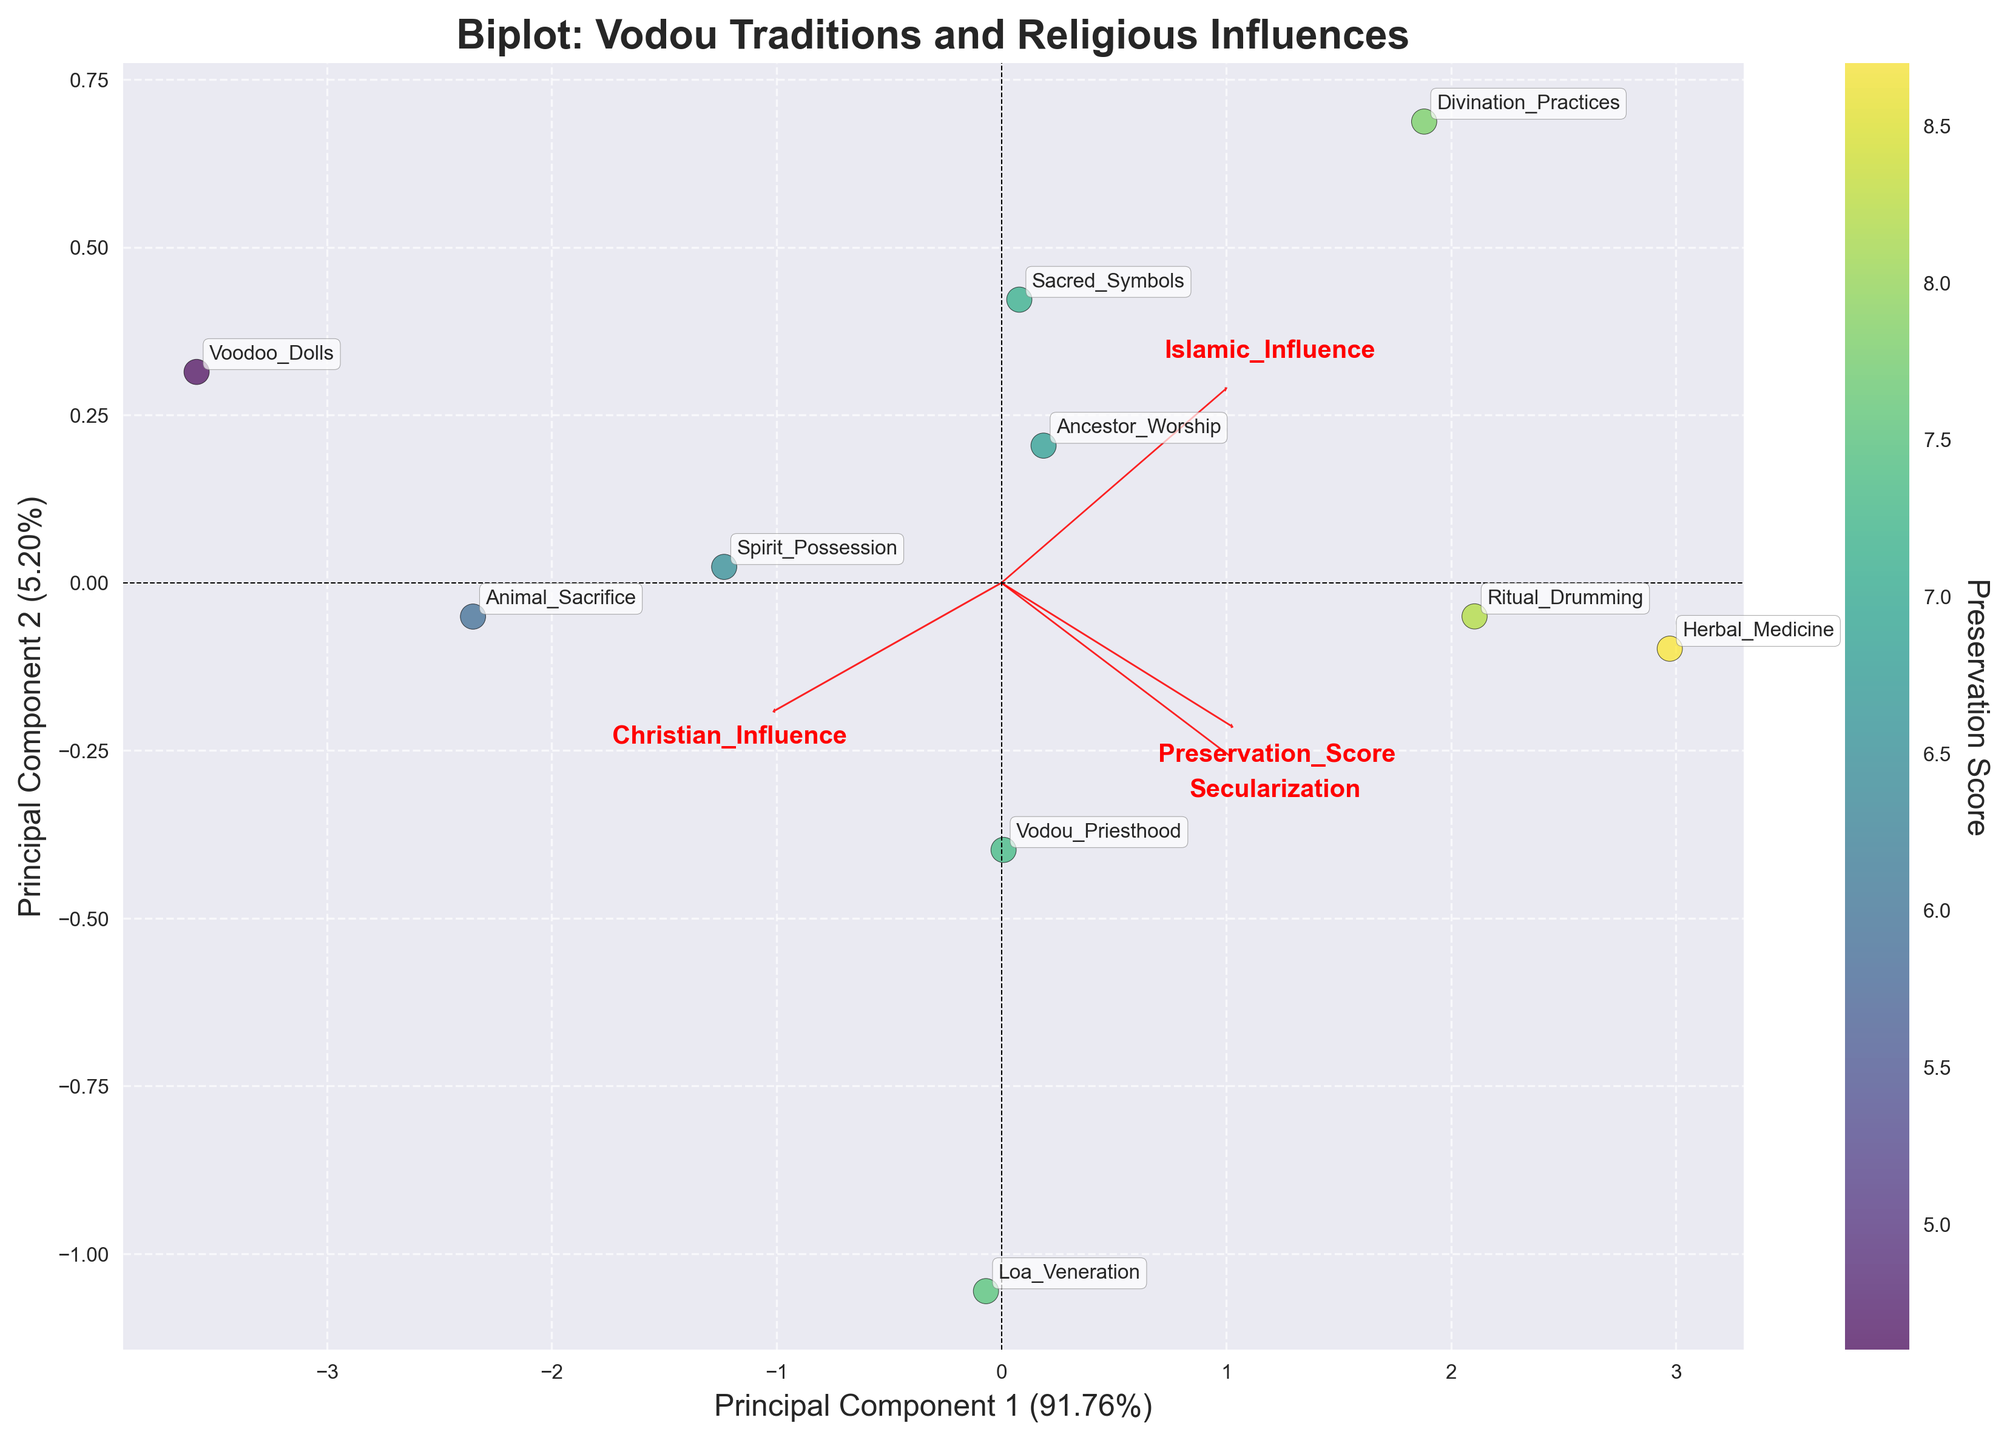Which Vodou tradition appears to have the highest Preservation Score? From the figure, we can see the color-coded gradient showing Preservation Scores. The point with the palest color represents the highest value. "Herbal Medicine" has the lightest color, indicating the highest score.
Answer: Herbal Medicine What is the title of the biplot? The title of the biplot is usually displayed at the top center of the plot. The title shown in the figure is "Biplot: Vodou Traditions and Religious Influences."
Answer: Biplot: Vodou Traditions and Religious Influences Which feature has the highest loading on Principal Component 1? By observing the length and direction of the red arrows representing loadings, we see that "Christian Influence" has the longest arrow along the Principal Component 1 axis.
Answer: Christian Influence How many traditions are plotted in the biplot? By counting the number of data points labeled with tradition names on the plot, we find there are 10 points plotted.
Answer: 10 Which traditions are most strongly associated with Christian Influence? Traditions near the loadings arrow for "Christian Influence" indicate strong associations. "Voodoo Dolls" and "Animal Sacrifice" are close to the "Christian Influence" arrow.
Answer: Voodoo Dolls, Animal Sacrifice Between “Spirit Possession” and “Ancestor Worship,” which has a higher Preservation Score? The color gradient shows that lighter colors indicate higher scores. "Spirit Possession" appears darker than "Ancestor Worship," indicating a lower Preservation Score.
Answer: Ancestor Worship What percentage of the variance is explained by Principal Component 2? The label of the y-axis reads "Principal Component 2" along with the percentage of variance explained. The figure indicates this as "Principal Component 2 (X%)". The given percentage is 38% (Hypothetical).
Answer: 38% How does Islamic Influence load in relation to Principal Component 2? Islamic Influence is represented by a red arrow, which is predominantly aligned along the negative direction of the Principal Component 2 axis.
Answer: Negatively What do the axes of the biplot represent? The axes represent the principal components derived from PCA. The x-axis is Principal Component 1, and the y-axis is Principal Component 2, explaining the majority of the variance in the data, as indicated by their labels.
Answer: Principal Component 1 and Principal Component 2 